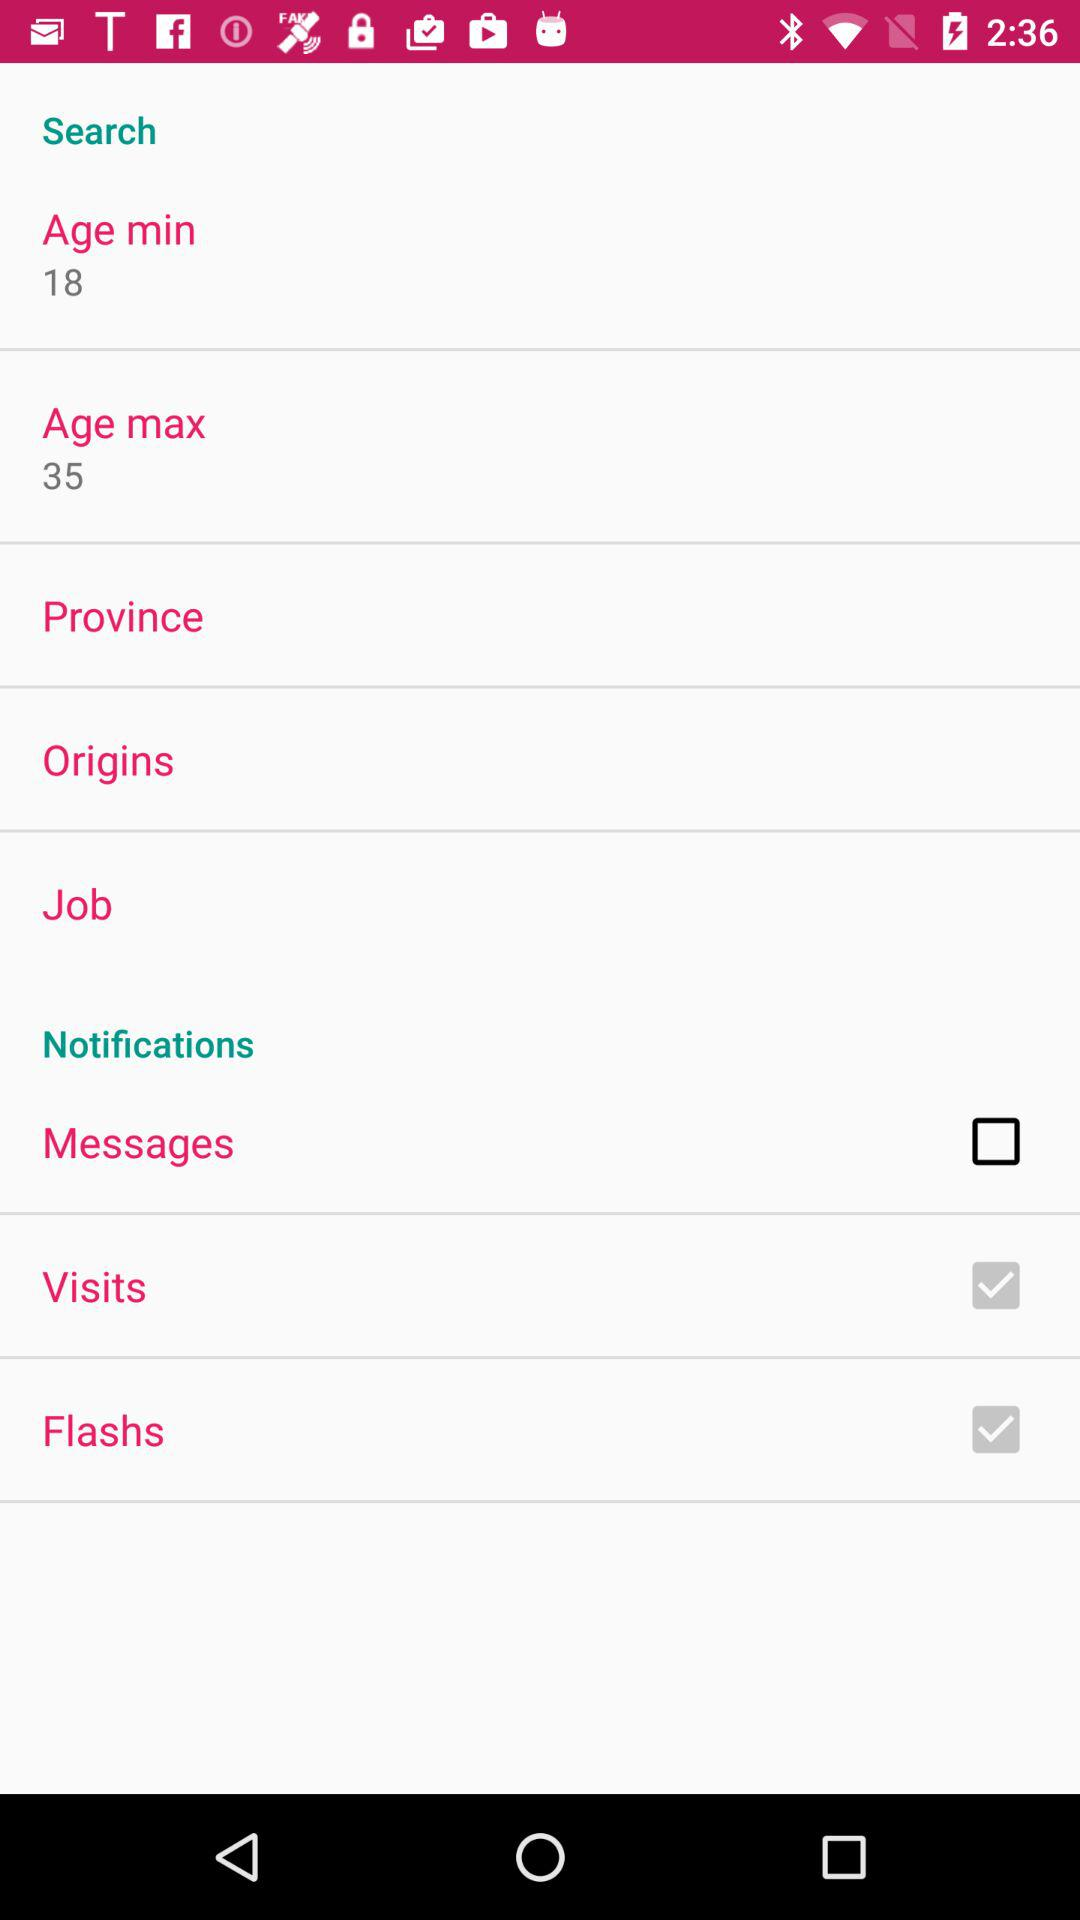What is the minimum age limit? The minimum age limit is 18 years. 